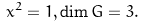<formula> <loc_0><loc_0><loc_500><loc_500>x ^ { 2 } = 1 , \dim G = 3 .</formula> 